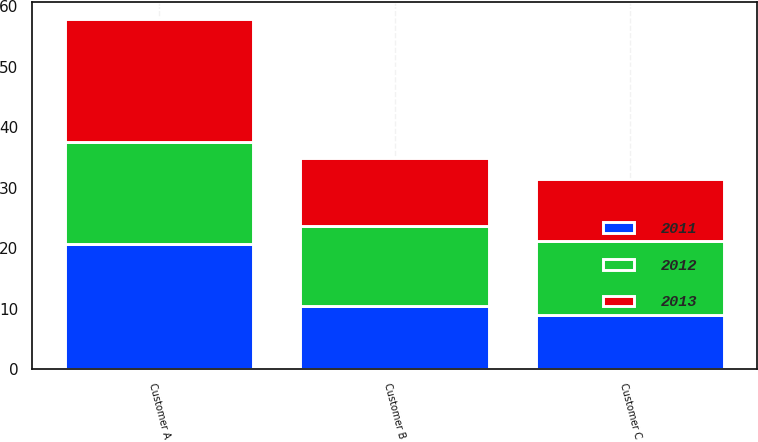<chart> <loc_0><loc_0><loc_500><loc_500><stacked_bar_chart><ecel><fcel>Customer A<fcel>Customer B<fcel>Customer C<nl><fcel>2012<fcel>16.8<fcel>13.1<fcel>12.3<nl><fcel>2013<fcel>20.4<fcel>11.4<fcel>10.3<nl><fcel>2011<fcel>20.7<fcel>10.5<fcel>8.9<nl></chart> 